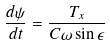<formula> <loc_0><loc_0><loc_500><loc_500>\frac { d \psi } { d t } = \frac { T _ { x } } { C \omega \sin \epsilon }</formula> 